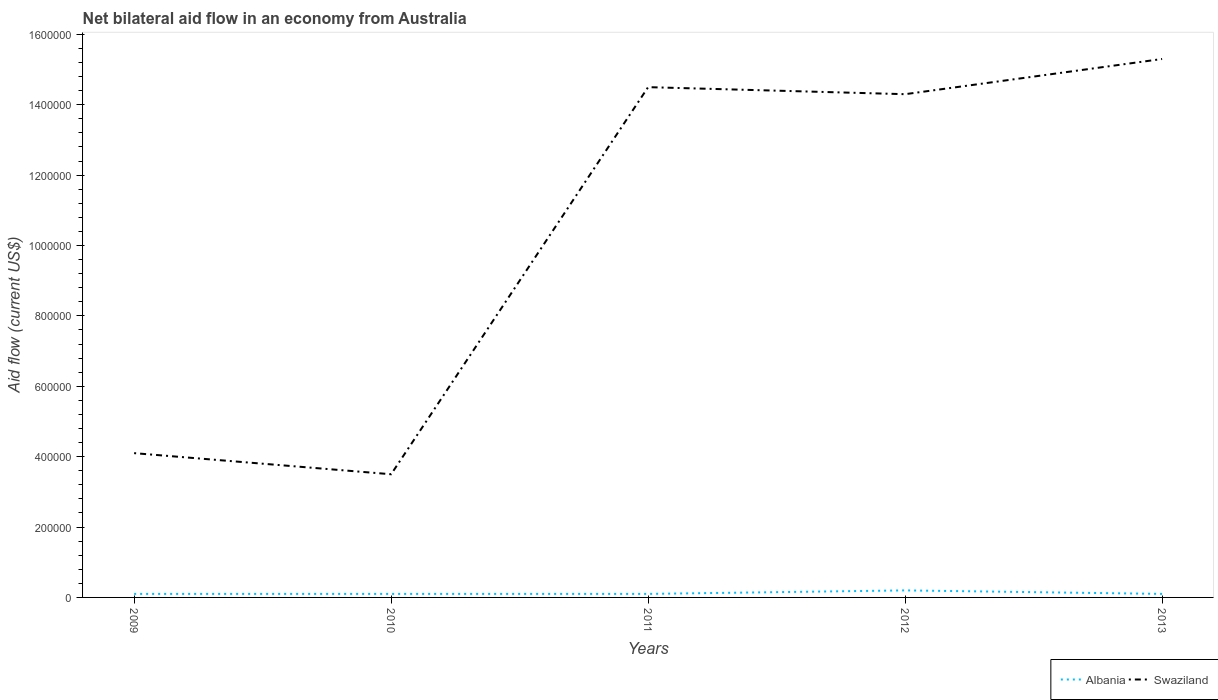Is the number of lines equal to the number of legend labels?
Offer a terse response. Yes. Across all years, what is the maximum net bilateral aid flow in Swaziland?
Your response must be concise. 3.50e+05. In which year was the net bilateral aid flow in Albania maximum?
Provide a short and direct response. 2009. What is the total net bilateral aid flow in Swaziland in the graph?
Your answer should be compact. -1.10e+06. What is the difference between the highest and the second highest net bilateral aid flow in Swaziland?
Ensure brevity in your answer.  1.18e+06. Does the graph contain grids?
Make the answer very short. No. Where does the legend appear in the graph?
Offer a terse response. Bottom right. How many legend labels are there?
Offer a terse response. 2. What is the title of the graph?
Give a very brief answer. Net bilateral aid flow in an economy from Australia. Does "Norway" appear as one of the legend labels in the graph?
Give a very brief answer. No. What is the label or title of the X-axis?
Provide a short and direct response. Years. What is the label or title of the Y-axis?
Provide a succinct answer. Aid flow (current US$). What is the Aid flow (current US$) of Swaziland in 2010?
Your answer should be very brief. 3.50e+05. What is the Aid flow (current US$) in Albania in 2011?
Offer a very short reply. 10000. What is the Aid flow (current US$) of Swaziland in 2011?
Give a very brief answer. 1.45e+06. What is the Aid flow (current US$) in Albania in 2012?
Make the answer very short. 2.00e+04. What is the Aid flow (current US$) in Swaziland in 2012?
Give a very brief answer. 1.43e+06. What is the Aid flow (current US$) of Albania in 2013?
Offer a very short reply. 10000. What is the Aid flow (current US$) in Swaziland in 2013?
Provide a succinct answer. 1.53e+06. Across all years, what is the maximum Aid flow (current US$) in Albania?
Make the answer very short. 2.00e+04. Across all years, what is the maximum Aid flow (current US$) of Swaziland?
Keep it short and to the point. 1.53e+06. Across all years, what is the minimum Aid flow (current US$) in Albania?
Your answer should be compact. 10000. What is the total Aid flow (current US$) in Albania in the graph?
Offer a terse response. 6.00e+04. What is the total Aid flow (current US$) of Swaziland in the graph?
Your answer should be compact. 5.17e+06. What is the difference between the Aid flow (current US$) in Albania in 2009 and that in 2010?
Provide a succinct answer. 0. What is the difference between the Aid flow (current US$) of Swaziland in 2009 and that in 2011?
Make the answer very short. -1.04e+06. What is the difference between the Aid flow (current US$) in Albania in 2009 and that in 2012?
Ensure brevity in your answer.  -10000. What is the difference between the Aid flow (current US$) in Swaziland in 2009 and that in 2012?
Give a very brief answer. -1.02e+06. What is the difference between the Aid flow (current US$) of Albania in 2009 and that in 2013?
Provide a short and direct response. 0. What is the difference between the Aid flow (current US$) of Swaziland in 2009 and that in 2013?
Provide a succinct answer. -1.12e+06. What is the difference between the Aid flow (current US$) of Swaziland in 2010 and that in 2011?
Provide a short and direct response. -1.10e+06. What is the difference between the Aid flow (current US$) in Swaziland in 2010 and that in 2012?
Keep it short and to the point. -1.08e+06. What is the difference between the Aid flow (current US$) of Swaziland in 2010 and that in 2013?
Make the answer very short. -1.18e+06. What is the difference between the Aid flow (current US$) in Swaziland in 2011 and that in 2012?
Keep it short and to the point. 2.00e+04. What is the difference between the Aid flow (current US$) in Swaziland in 2011 and that in 2013?
Your answer should be compact. -8.00e+04. What is the difference between the Aid flow (current US$) in Albania in 2012 and that in 2013?
Your answer should be very brief. 10000. What is the difference between the Aid flow (current US$) in Albania in 2009 and the Aid flow (current US$) in Swaziland in 2010?
Your answer should be very brief. -3.40e+05. What is the difference between the Aid flow (current US$) in Albania in 2009 and the Aid flow (current US$) in Swaziland in 2011?
Ensure brevity in your answer.  -1.44e+06. What is the difference between the Aid flow (current US$) in Albania in 2009 and the Aid flow (current US$) in Swaziland in 2012?
Your answer should be compact. -1.42e+06. What is the difference between the Aid flow (current US$) in Albania in 2009 and the Aid flow (current US$) in Swaziland in 2013?
Provide a succinct answer. -1.52e+06. What is the difference between the Aid flow (current US$) of Albania in 2010 and the Aid flow (current US$) of Swaziland in 2011?
Make the answer very short. -1.44e+06. What is the difference between the Aid flow (current US$) of Albania in 2010 and the Aid flow (current US$) of Swaziland in 2012?
Give a very brief answer. -1.42e+06. What is the difference between the Aid flow (current US$) of Albania in 2010 and the Aid flow (current US$) of Swaziland in 2013?
Keep it short and to the point. -1.52e+06. What is the difference between the Aid flow (current US$) of Albania in 2011 and the Aid flow (current US$) of Swaziland in 2012?
Give a very brief answer. -1.42e+06. What is the difference between the Aid flow (current US$) of Albania in 2011 and the Aid flow (current US$) of Swaziland in 2013?
Keep it short and to the point. -1.52e+06. What is the difference between the Aid flow (current US$) of Albania in 2012 and the Aid flow (current US$) of Swaziland in 2013?
Offer a terse response. -1.51e+06. What is the average Aid flow (current US$) in Albania per year?
Offer a terse response. 1.20e+04. What is the average Aid flow (current US$) in Swaziland per year?
Provide a short and direct response. 1.03e+06. In the year 2009, what is the difference between the Aid flow (current US$) in Albania and Aid flow (current US$) in Swaziland?
Give a very brief answer. -4.00e+05. In the year 2011, what is the difference between the Aid flow (current US$) in Albania and Aid flow (current US$) in Swaziland?
Offer a very short reply. -1.44e+06. In the year 2012, what is the difference between the Aid flow (current US$) in Albania and Aid flow (current US$) in Swaziland?
Give a very brief answer. -1.41e+06. In the year 2013, what is the difference between the Aid flow (current US$) in Albania and Aid flow (current US$) in Swaziland?
Give a very brief answer. -1.52e+06. What is the ratio of the Aid flow (current US$) in Albania in 2009 to that in 2010?
Provide a succinct answer. 1. What is the ratio of the Aid flow (current US$) in Swaziland in 2009 to that in 2010?
Offer a very short reply. 1.17. What is the ratio of the Aid flow (current US$) of Albania in 2009 to that in 2011?
Make the answer very short. 1. What is the ratio of the Aid flow (current US$) in Swaziland in 2009 to that in 2011?
Offer a terse response. 0.28. What is the ratio of the Aid flow (current US$) of Swaziland in 2009 to that in 2012?
Keep it short and to the point. 0.29. What is the ratio of the Aid flow (current US$) of Albania in 2009 to that in 2013?
Your answer should be very brief. 1. What is the ratio of the Aid flow (current US$) of Swaziland in 2009 to that in 2013?
Your answer should be very brief. 0.27. What is the ratio of the Aid flow (current US$) of Albania in 2010 to that in 2011?
Offer a very short reply. 1. What is the ratio of the Aid flow (current US$) of Swaziland in 2010 to that in 2011?
Give a very brief answer. 0.24. What is the ratio of the Aid flow (current US$) of Swaziland in 2010 to that in 2012?
Your answer should be compact. 0.24. What is the ratio of the Aid flow (current US$) of Albania in 2010 to that in 2013?
Provide a succinct answer. 1. What is the ratio of the Aid flow (current US$) in Swaziland in 2010 to that in 2013?
Give a very brief answer. 0.23. What is the ratio of the Aid flow (current US$) of Albania in 2011 to that in 2012?
Your response must be concise. 0.5. What is the ratio of the Aid flow (current US$) in Swaziland in 2011 to that in 2013?
Ensure brevity in your answer.  0.95. What is the ratio of the Aid flow (current US$) of Albania in 2012 to that in 2013?
Provide a succinct answer. 2. What is the ratio of the Aid flow (current US$) in Swaziland in 2012 to that in 2013?
Your answer should be compact. 0.93. What is the difference between the highest and the second highest Aid flow (current US$) of Albania?
Your answer should be compact. 10000. What is the difference between the highest and the second highest Aid flow (current US$) of Swaziland?
Your answer should be very brief. 8.00e+04. What is the difference between the highest and the lowest Aid flow (current US$) of Albania?
Your answer should be very brief. 10000. What is the difference between the highest and the lowest Aid flow (current US$) of Swaziland?
Keep it short and to the point. 1.18e+06. 